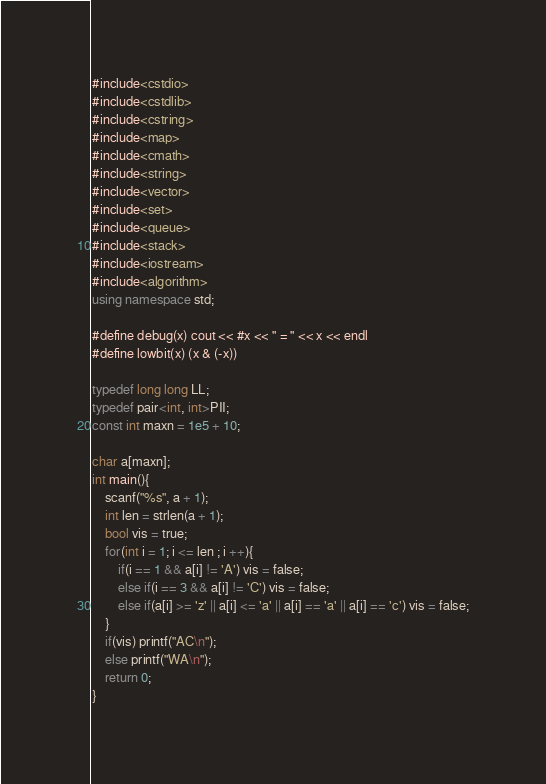<code> <loc_0><loc_0><loc_500><loc_500><_C++_>#include<cstdio>
#include<cstdlib>
#include<cstring>
#include<map>
#include<cmath>
#include<string>
#include<vector>
#include<set>
#include<queue>
#include<stack>
#include<iostream>
#include<algorithm>
using namespace std;

#define debug(x) cout << #x << " = " << x << endl
#define lowbit(x) (x & (-x))

typedef long long LL;
typedef pair<int, int>PII;
const int maxn = 1e5 + 10;

char a[maxn];
int main(){
	scanf("%s", a + 1);
	int len = strlen(a + 1);
	bool vis = true;
	for(int i = 1; i <= len ; i ++){
		if(i == 1 && a[i] != 'A') vis = false;
		else if(i == 3 && a[i] != 'C') vis = false;
		else if(a[i] >= 'z' || a[i] <= 'a' || a[i] == 'a' || a[i] == 'c') vis = false;
	}
	if(vis) printf("AC\n");
	else printf("WA\n");
	return 0;
}</code> 